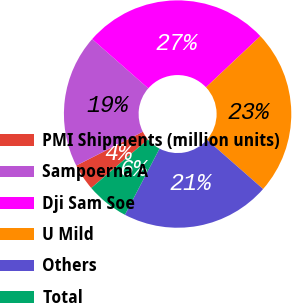Convert chart to OTSL. <chart><loc_0><loc_0><loc_500><loc_500><pie_chart><fcel>PMI Shipments (million units)<fcel>Sampoerna A<fcel>Dji Sam Soe<fcel>U Mild<fcel>Others<fcel>Total<nl><fcel>3.79%<fcel>18.94%<fcel>26.52%<fcel>23.48%<fcel>21.21%<fcel>6.06%<nl></chart> 